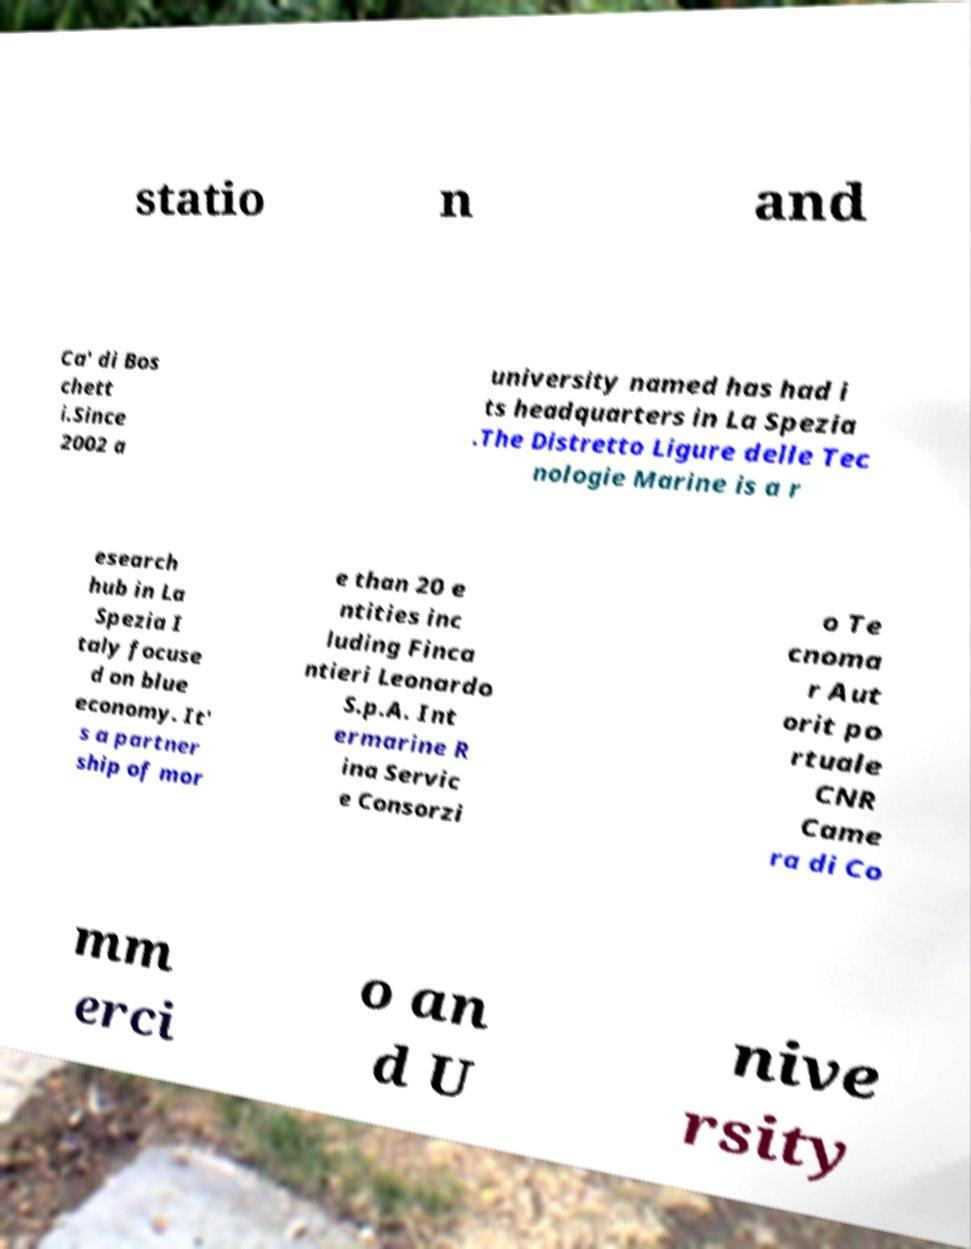Could you extract and type out the text from this image? statio n and Ca' di Bos chett i.Since 2002 a university named has had i ts headquarters in La Spezia .The Distretto Ligure delle Tec nologie Marine is a r esearch hub in La Spezia I taly focuse d on blue economy. It' s a partner ship of mor e than 20 e ntities inc luding Finca ntieri Leonardo S.p.A. Int ermarine R ina Servic e Consorzi o Te cnoma r Aut orit po rtuale CNR Came ra di Co mm erci o an d U nive rsity 